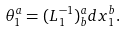<formula> <loc_0><loc_0><loc_500><loc_500>\theta _ { 1 } ^ { a } = ( L _ { 1 } ^ { - 1 } ) _ { b } ^ { a } d x _ { 1 } ^ { b } .</formula> 